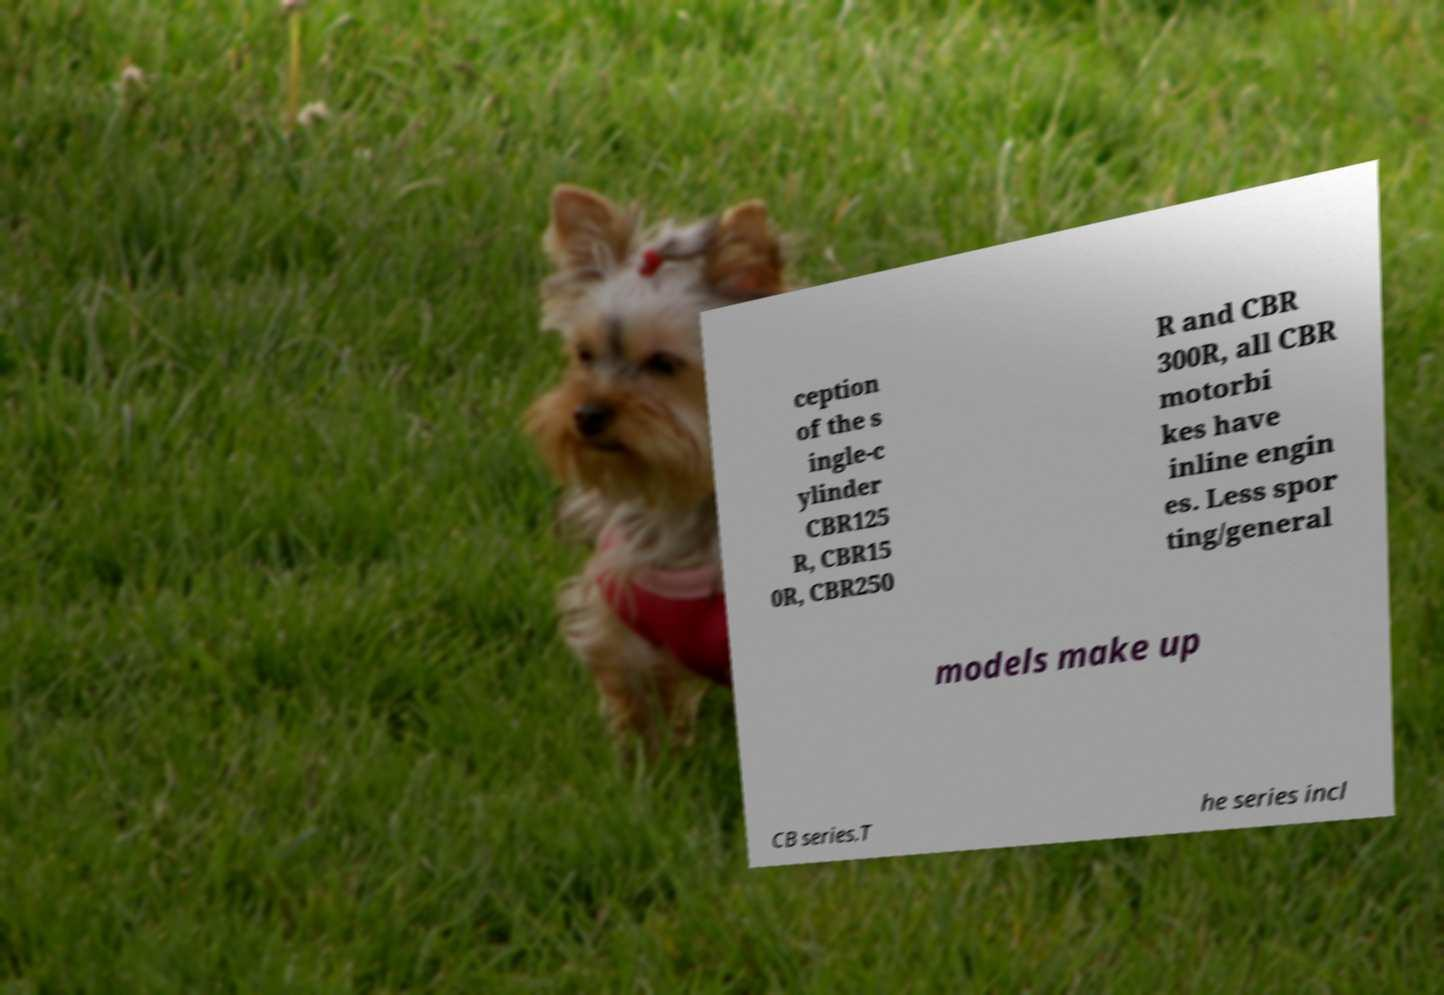Please identify and transcribe the text found in this image. ception of the s ingle-c ylinder CBR125 R, CBR15 0R, CBR250 R and CBR 300R, all CBR motorbi kes have inline engin es. Less spor ting/general models make up CB series.T he series incl 